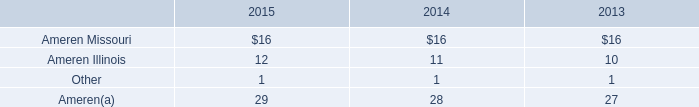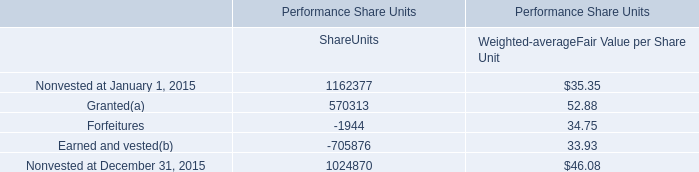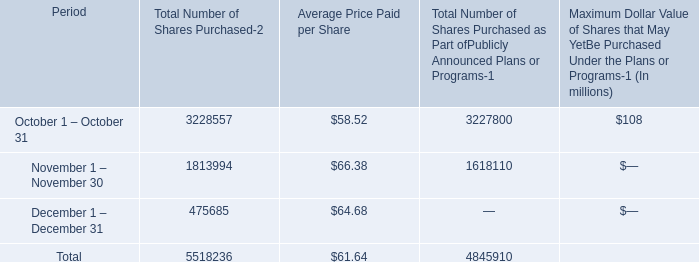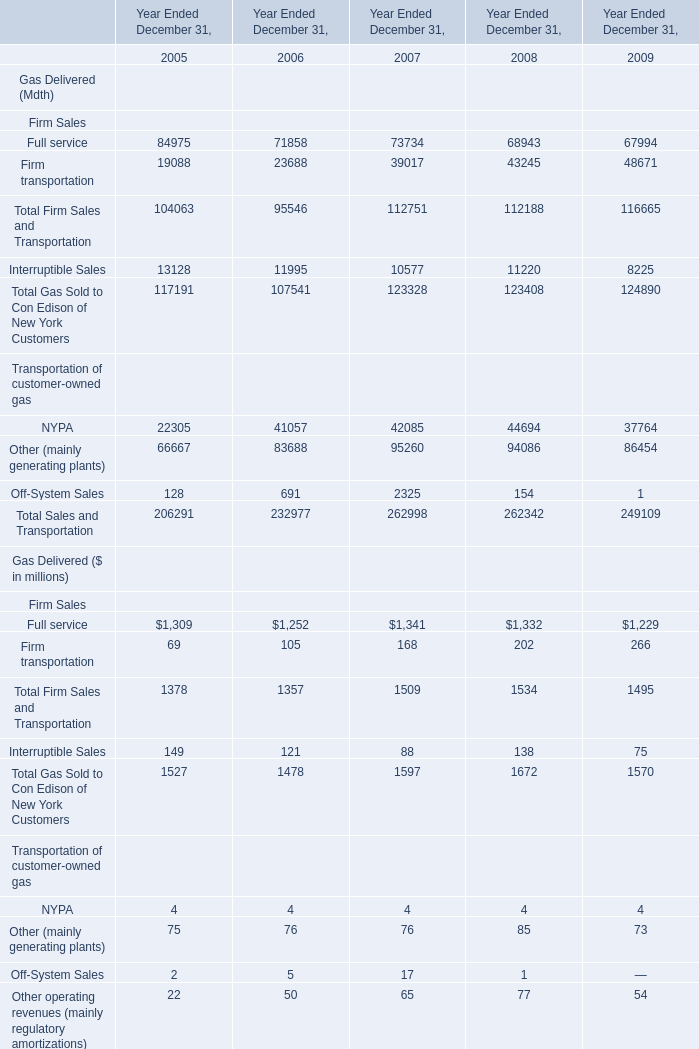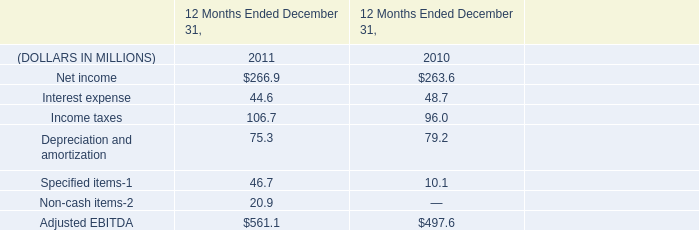What was the average value of the Total Firm Sales and Transportation and Interruptible Sales in the years where Firm transportation is positive? (in million) 
Computations: ((116665 + 8225) / 2)
Answer: 62445.0. 